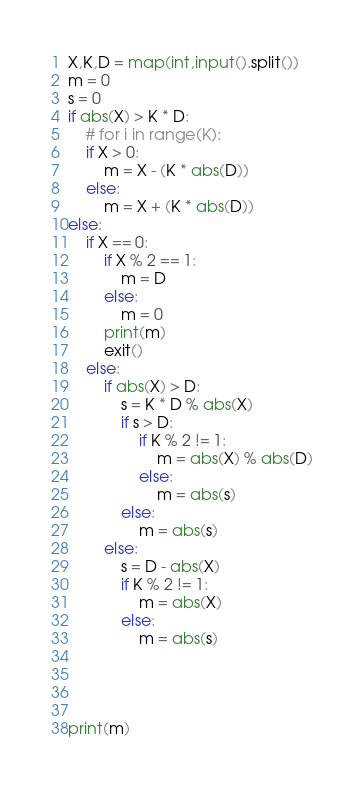<code> <loc_0><loc_0><loc_500><loc_500><_Python_>X,K,D = map(int,input().split())
m = 0
s = 0
if abs(X) > K * D:
    # for i in range(K):
    if X > 0:
        m = X - (K * abs(D))
    else:
        m = X + (K * abs(D))
else:
    if X == 0:
        if X % 2 == 1:
            m = D
        else:
            m = 0
        print(m)
        exit()
    else:
        if abs(X) > D:
            s = K * D % abs(X)
            if s > D:
                if K % 2 != 1:
                    m = abs(X) % abs(D)
                else:
                    m = abs(s)
            else:
                m = abs(s)     
        else:
            s = D - abs(X)
            if K % 2 != 1:
                m = abs(X)
            else:
                m = abs(s)


       

print(m)</code> 